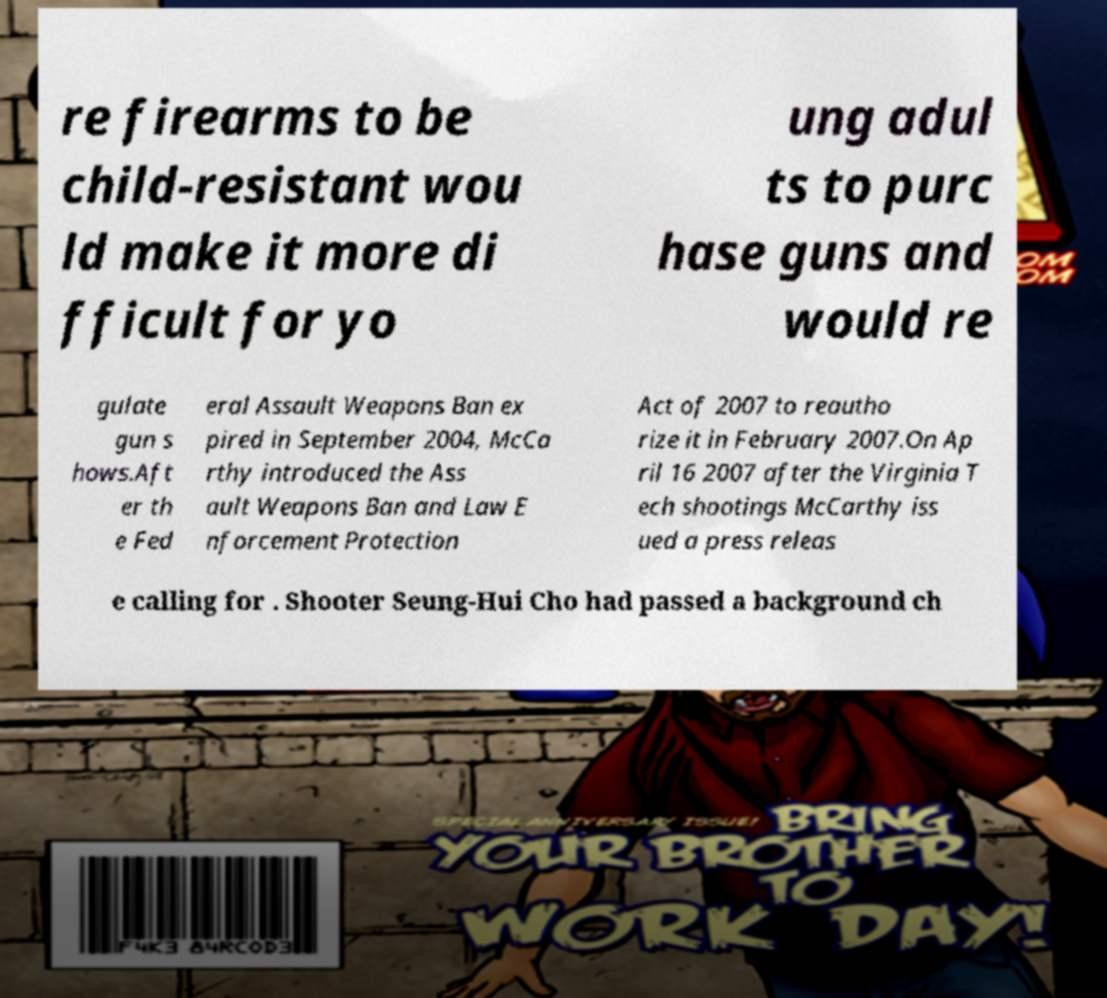Please read and relay the text visible in this image. What does it say? re firearms to be child-resistant wou ld make it more di fficult for yo ung adul ts to purc hase guns and would re gulate gun s hows.Aft er th e Fed eral Assault Weapons Ban ex pired in September 2004, McCa rthy introduced the Ass ault Weapons Ban and Law E nforcement Protection Act of 2007 to reautho rize it in February 2007.On Ap ril 16 2007 after the Virginia T ech shootings McCarthy iss ued a press releas e calling for . Shooter Seung-Hui Cho had passed a background ch 